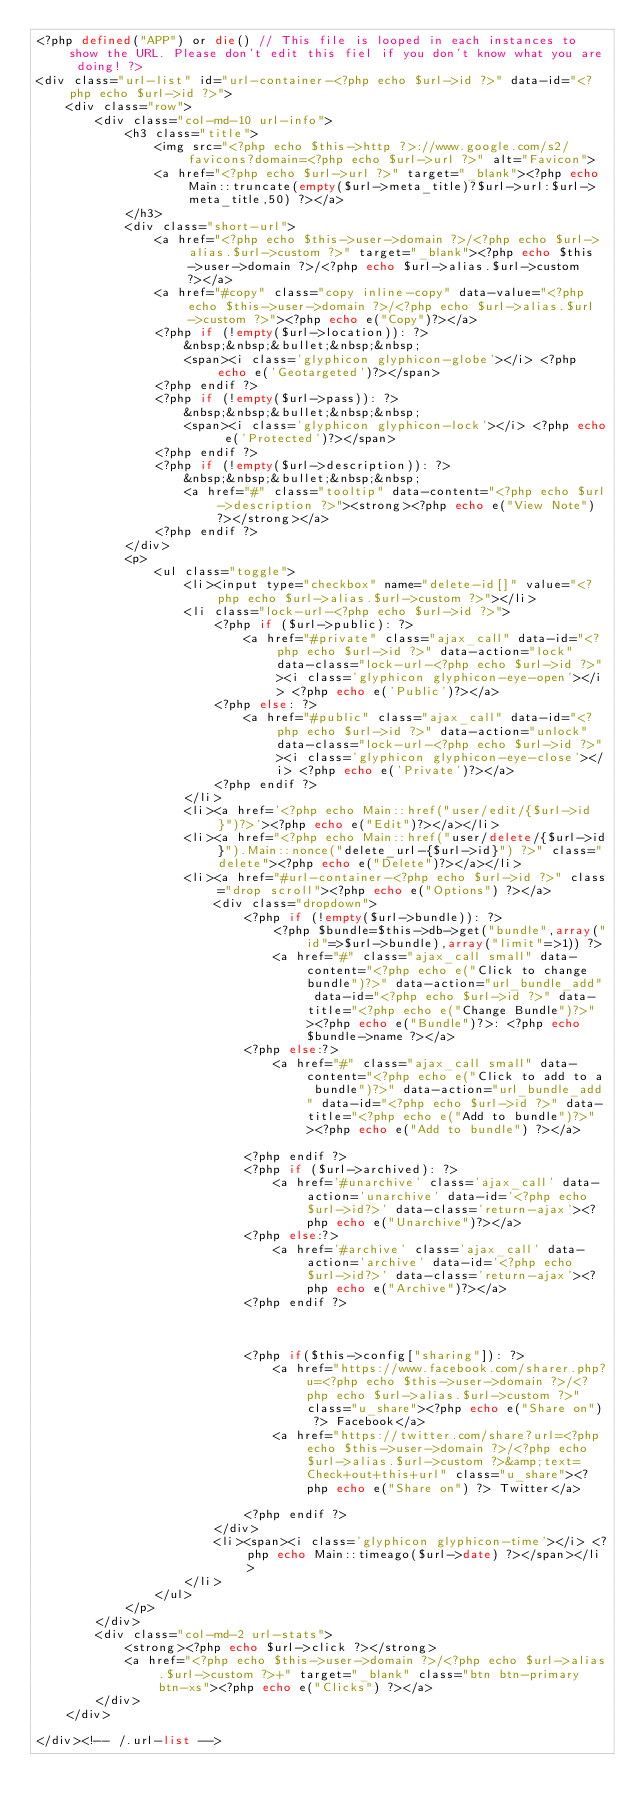Convert code to text. <code><loc_0><loc_0><loc_500><loc_500><_PHP_><?php defined("APP") or die() // This file is looped in each instances to show the URL. Please don't edit this fiel if you don't know what you are doing! ?>
<div class="url-list" id="url-container-<?php echo $url->id ?>" data-id="<?php echo $url->id ?>">
	<div class="row">
		<div class="col-md-10 url-info">
			<h3 class="title">
				<img src="<?php echo $this->http ?>://www.google.com/s2/favicons?domain=<?php echo $url->url ?>" alt="Favicon">
				<a href="<?php echo $url->url ?>" target="_blank"><?php echo Main::truncate(empty($url->meta_title)?$url->url:$url->meta_title,50) ?></a>
			</h3>
			<div class="short-url">
				<a href="<?php echo $this->user->domain ?>/<?php echo $url->alias.$url->custom ?>" target="_blank"><?php echo $this->user->domain ?>/<?php echo $url->alias.$url->custom ?></a>
				<a href="#copy" class="copy inline-copy" data-value="<?php echo $this->user->domain ?>/<?php echo $url->alias.$url->custom ?>"><?php echo e("Copy")?></a>				
				<?php if (!empty($url->location)): ?>
					&nbsp;&nbsp;&bullet;&nbsp;&nbsp;
					<span><i class='glyphicon glyphicon-globe'></i> <?php echo e('Geotargeted')?></span>
				<?php endif ?>
				<?php if (!empty($url->pass)): ?>
					&nbsp;&nbsp;&bullet;&nbsp;&nbsp;
					<span><i class='glyphicon glyphicon-lock'></i> <?php echo e('Protected')?></span>
				<?php endif ?>				
				<?php if (!empty($url->description)): ?>
					&nbsp;&nbsp;&bullet;&nbsp;&nbsp;					
					<a href="#" class="tooltip" data-content="<?php echo $url->description ?>"><strong><?php echo e("View Note") ?></strong></a>
				<?php endif ?>								
			</div>
			<p>
				<ul class="toggle">
					<li><input type="checkbox" name="delete-id[]" value="<?php echo $url->alias.$url->custom ?>"></li>
					<li class="lock-url-<?php echo $url->id ?>">
						<?php if ($url->public): ?>
							<a href="#private" class="ajax_call" data-id="<?php echo $url->id ?>" data-action="lock" data-class="lock-url-<?php echo $url->id ?>"><i class='glyphicon glyphicon-eye-open'></i> <?php echo e('Public')?></a>
						<?php else: ?>
							<a href="#public" class="ajax_call" data-id="<?php echo $url->id ?>" data-action="unlock" data-class="lock-url-<?php echo $url->id ?>"><i class='glyphicon glyphicon-eye-close'></i> <?php echo e('Private')?></a>
						<?php endif ?>
					</li>
					<li><a href='<?php echo Main::href("user/edit/{$url->id}")?>'><?php echo e("Edit")?></a></li>
					<li><a href="<?php echo Main::href("user/delete/{$url->id}").Main::nonce("delete_url-{$url->id}") ?>" class="delete"><?php echo e("Delete")?></a></li>
					<li><a href="#url-container-<?php echo $url->id ?>" class="drop scroll"><?php echo e("Options") ?></a>
						<div class="dropdown">			
							<?php if (!empty($url->bundle)): ?>
								<?php $bundle=$this->db->get("bundle",array("id"=>$url->bundle),array("limit"=>1)) ?>
								<a href="#" class="ajax_call small" data-content="<?php echo e("Click to change bundle")?>" data-action="url_bundle_add" data-id="<?php echo $url->id ?>" data-title="<?php echo e("Change Bundle")?>"><?php echo e("Bundle")?>: <?php echo $bundle->name ?></a>					
							<?php else:?>
								<a href="#" class="ajax_call small" data-content="<?php echo e("Click to add to a bundle")?>" data-action="url_bundle_add" data-id="<?php echo $url->id ?>" data-title="<?php echo e("Add to bundle")?>"><?php echo e("Add to bundle") ?></a>					
							<?php endif ?>			
							<?php if ($url->archived): ?>
								<a href='#unarchive' class='ajax_call' data-action='unarchive' data-id='<?php echo $url->id?>' data-class='return-ajax'><?php echo e("Unarchive")?></a>
							<?php else:?>
								<a href='#archive' class='ajax_call' data-action='archive' data-id='<?php echo $url->id?>' data-class='return-ajax'><?php echo e("Archive")?></a>
							<?php endif ?>																																
							<?php if($this->config["sharing"]): ?>
								<a href="https://www.facebook.com/sharer.php?u=<?php echo $this->user->domain ?>/<?php echo $url->alias.$url->custom ?>" class="u_share"><?php echo e("Share on") ?> Facebook</a>
								<a href="https://twitter.com/share?url=<?php echo $this->user->domain ?>/<?php echo $url->alias.$url->custom ?>&amp;text=Check+out+this+url" class="u_share"><?php echo e("Share on") ?> Twitter</a>							
							<?php endif ?>
						</div>	
						<li><span><i class='glyphicon glyphicon-time'></i> <?php echo Main::timeago($url->date) ?></span></li>						
					</li>
				</ul>				
			</p>
		</div>
		<div class="col-md-2 url-stats">
			<strong><?php echo $url->click ?></strong>
			<a href="<?php echo $this->user->domain ?>/<?php echo $url->alias.$url->custom ?>+" target="_blank" class="btn btn-primary btn-xs"><?php echo e("Clicks") ?></a>
		</div>
	</div>

</div><!-- /.url-list -->		</code> 